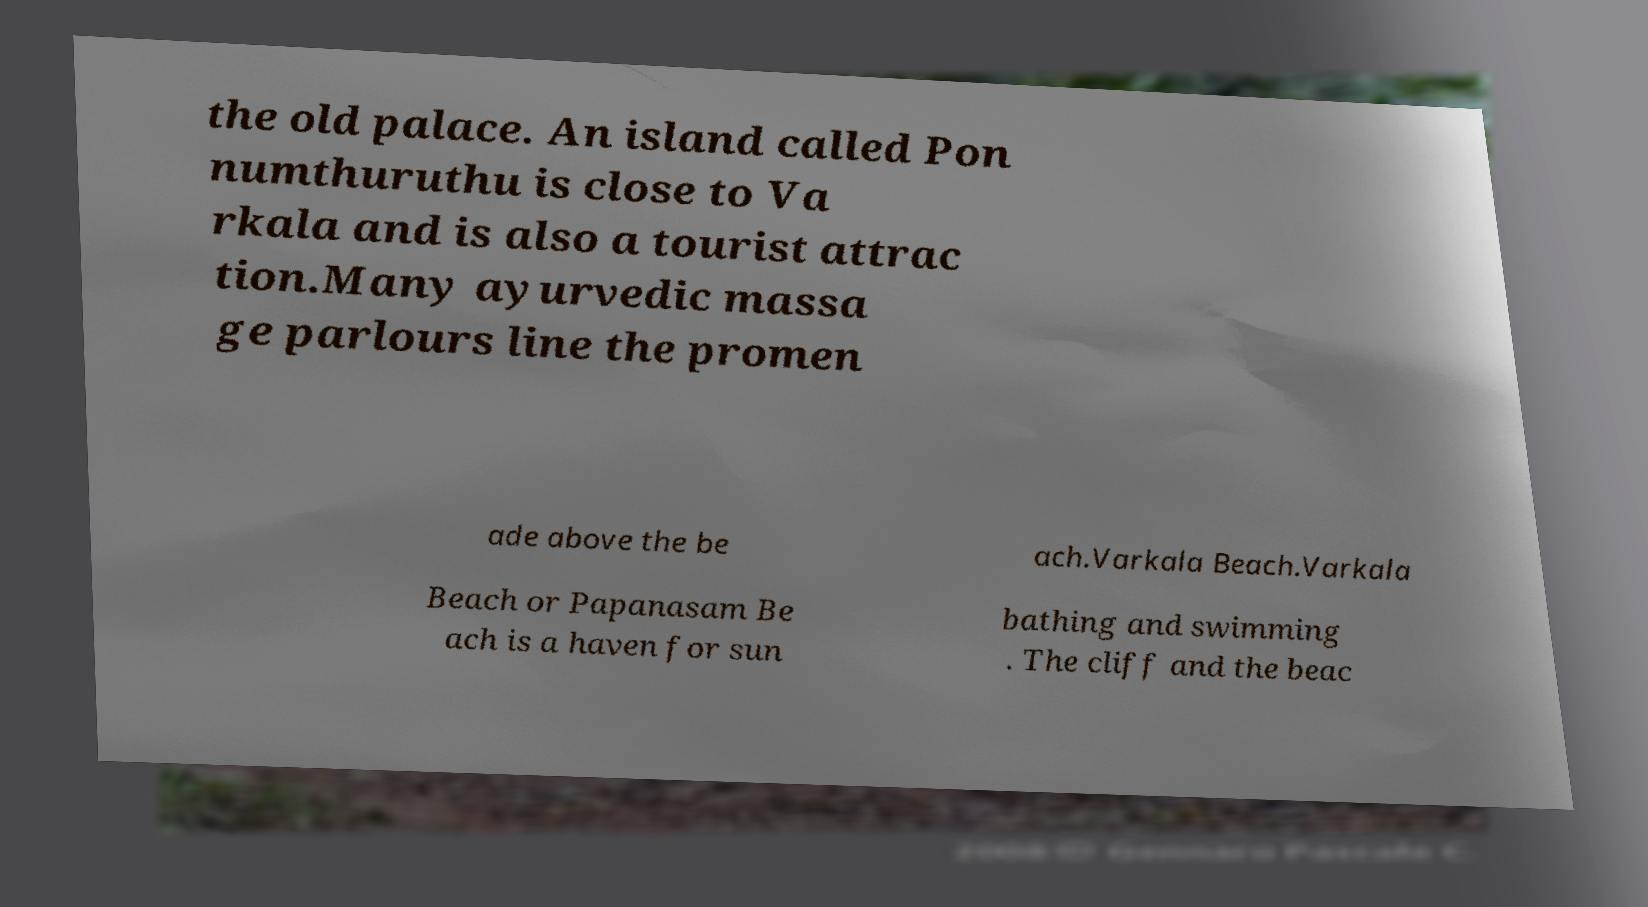I need the written content from this picture converted into text. Can you do that? the old palace. An island called Pon numthuruthu is close to Va rkala and is also a tourist attrac tion.Many ayurvedic massa ge parlours line the promen ade above the be ach.Varkala Beach.Varkala Beach or Papanasam Be ach is a haven for sun bathing and swimming . The cliff and the beac 